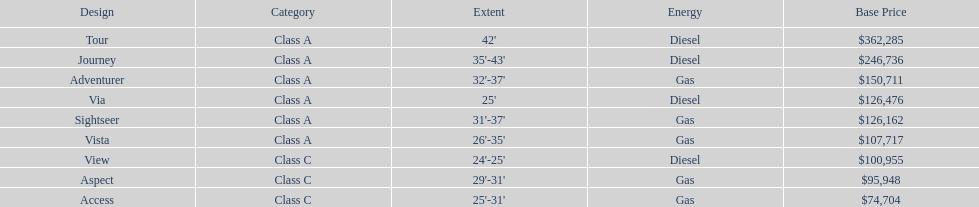What is the price of bot the via and tour models combined? $488,761. 